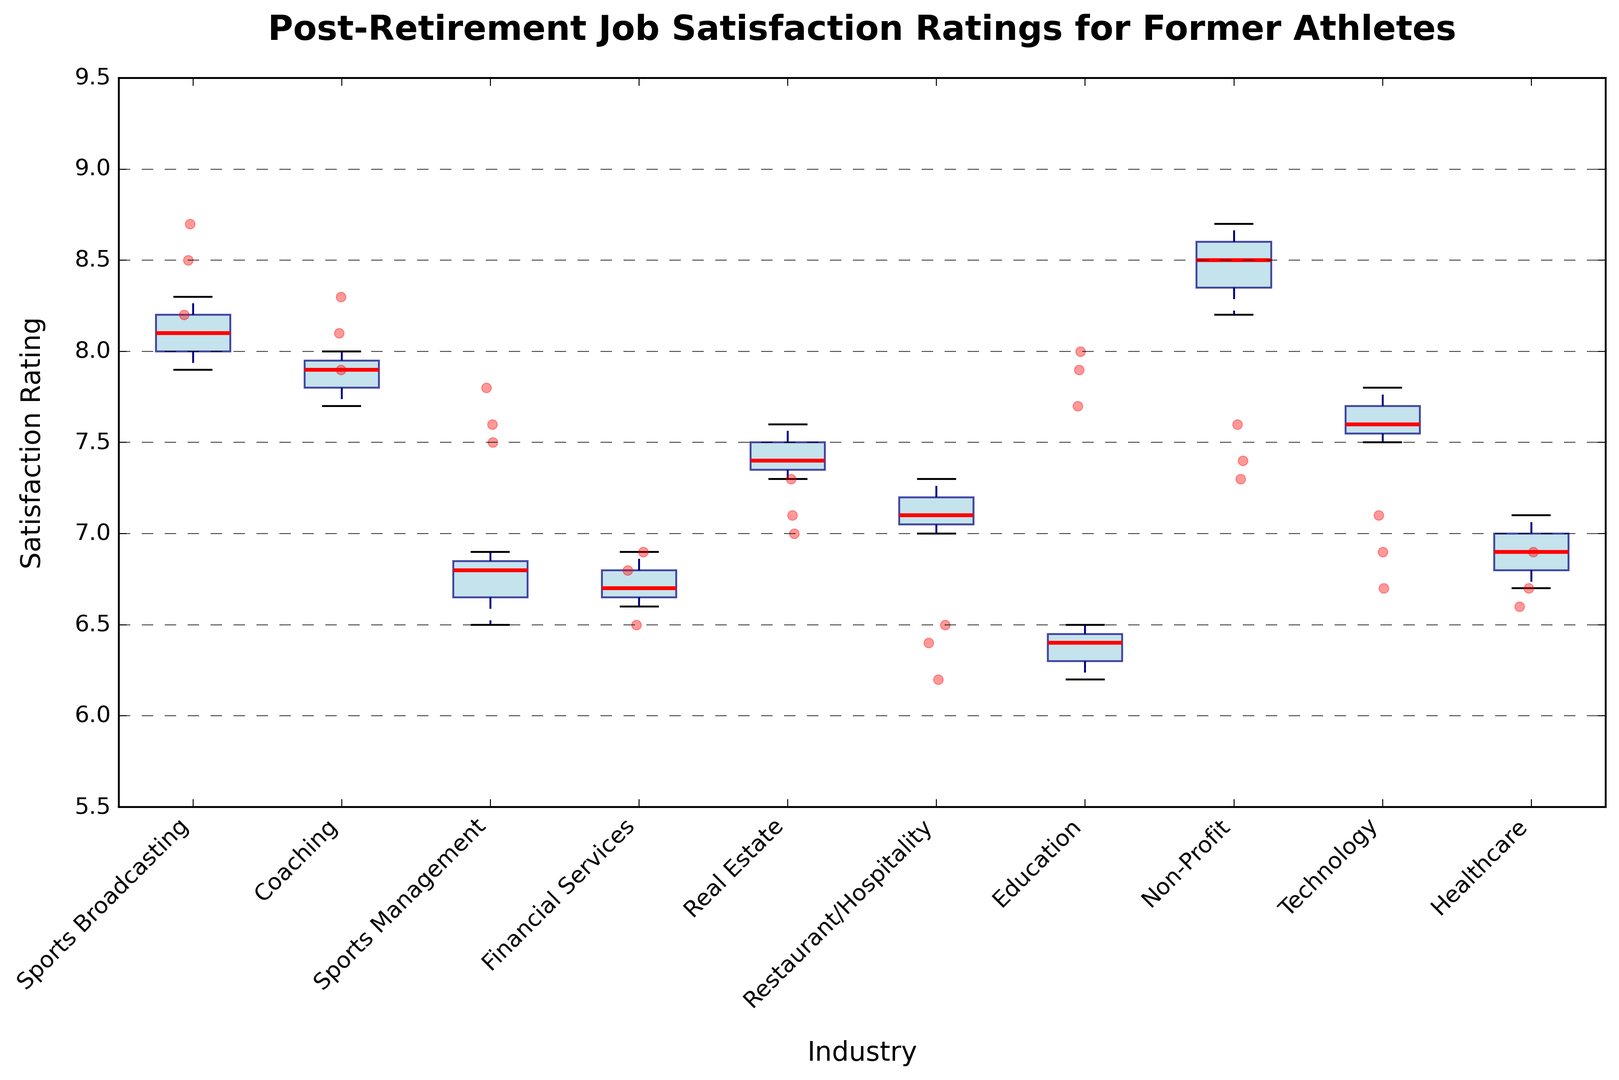Which industry has the highest median job satisfaction rating? Look at the red line inside each box, which represents the median. From the plot, it is clear that the median satisfaction rating for Sports Broadcasting is the highest.
Answer: Sports Broadcasting How does the median satisfaction rating of Coaching compare to Financial Services? Compare the red lines (medians) for Coaching and Financial Services. Coaching has a higher median satisfaction rating than Financial Services.
Answer: Coaching is higher Which industry shows the widest range of job satisfaction ratings? Look at the length of the vertical lines (whiskers) extending from the boxes. Sports Broadcasting has the widest range from the lowest to the highest satisfaction ratings.
Answer: Sports Broadcasting What is the lower quartile (25th percentile) satisfaction rating for Technology? Identify the bottom of the box for Technology; this is the lower quartile. The lower quartile for Technology is around 6.7.
Answer: 6.7 Which industry has the smallest interquartile range (IQR) for job satisfaction ratings? The IQR is the height of the box. The smallest IQR corresponds to the shortest box. Financial Services has one of the smallest IQRs.
Answer: Financial Services How much higher is the upper quartile (75th percentile) for Education compared to Restaurant/Hospitality? Look at the top of the box for both industries. The upper quartile for Education is approximately 8.0, and for Restaurant/Hospitality, it is around 6.7. The difference is 8.0 - 6.7 = 1.3.
Answer: 1.3 Are there any industries without outliers? Outliers are represented by separate orange dots. Coaching and Financial Services are examples of industries with no visible outliers.
Answer: Coaching and Financial Services Which industry has the lowest median satisfaction rating? Look at the red line (median) that is lowest on the vertical axis. Restaurant/Hospitality has the lowest median satisfaction rating.
Answer: Restaurant/Hospitality 